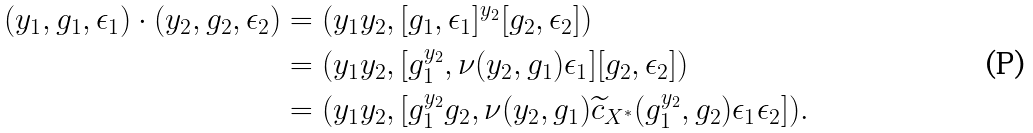Convert formula to latex. <formula><loc_0><loc_0><loc_500><loc_500>( y _ { 1 } , g _ { 1 } , \epsilon _ { 1 } ) \cdot ( y _ { 2 } , g _ { 2 } , \epsilon _ { 2 } ) & = ( y _ { 1 } y _ { 2 } , [ g _ { 1 } , \epsilon _ { 1 } ] ^ { y _ { 2 } } [ g _ { 2 } , \epsilon _ { 2 } ] ) \\ & = ( y _ { 1 } y _ { 2 } , [ g _ { 1 } ^ { y _ { 2 } } , \nu ( y _ { 2 } , g _ { 1 } ) \epsilon _ { 1 } ] [ g _ { 2 } , \epsilon _ { 2 } ] ) \\ & = ( y _ { 1 } y _ { 2 } , [ g _ { 1 } ^ { y _ { 2 } } g _ { 2 } , \nu ( y _ { 2 } , g _ { 1 } ) \widetilde { c } _ { X ^ { \ast } } ( g _ { 1 } ^ { y _ { 2 } } , g _ { 2 } ) \epsilon _ { 1 } \epsilon _ { 2 } ] ) .</formula> 